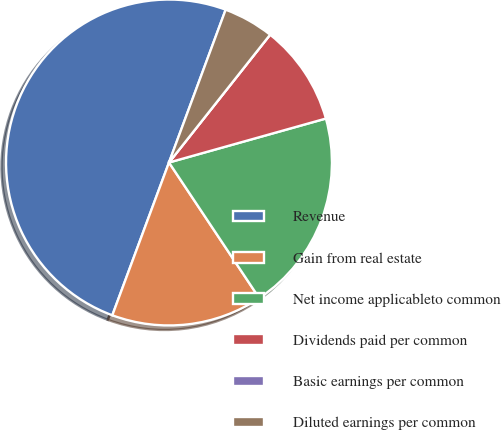Convert chart to OTSL. <chart><loc_0><loc_0><loc_500><loc_500><pie_chart><fcel>Revenue<fcel>Gain from real estate<fcel>Net income applicableto common<fcel>Dividends paid per common<fcel>Basic earnings per common<fcel>Diluted earnings per common<nl><fcel>50.0%<fcel>15.0%<fcel>20.0%<fcel>10.0%<fcel>0.0%<fcel>5.0%<nl></chart> 